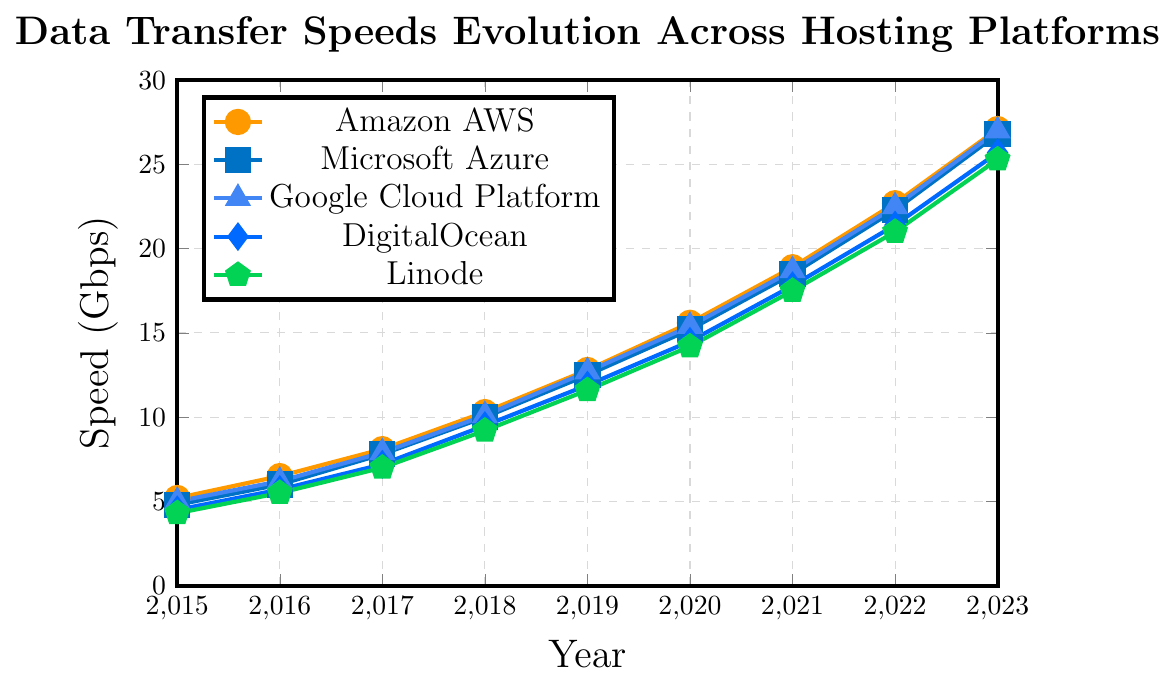Which hosting platform had the highest data transfer speed in 2023? Look at the data transfer speeds for the year 2023 across all platforms. Amazon AWS has the highest speed with 27.1 Gbps.
Answer: Amazon AWS What is the difference in data transfer speeds between Google Cloud Platform and Linode in 2019? In 2019, Google Cloud Platform had a speed of 12.7 Gbps, and Linode had a speed of 11.6 Gbps. Subtract Linode's speed from Google Cloud Platform's speed: 12.7 - 11.6 = 1.1 Gbps.
Answer: 1.1 Gbps Which hosting platform showed the most significant increase in data transfer speed between 2021 and 2023? Calculate the difference in data transfer speeds between 2021 and 2023 for each platform: 
- Amazon AWS: 27.1 - 18.9 = 8.2 
- Microsoft Azure: 26.8 - 18.5 = 8.3 
- Google Cloud Platform: 27.0 - 18.7 = 8.3 
- DigitalOcean: 25.7 - 17.8 = 7.9 
- Linode: 25.3 - 17.5 = 7.8 
Microsoft Azure and Google Cloud Platform tie with the highest increase of 8.3 Gbps.
Answer: Microsoft Azure and Google Cloud Platform Compare the average data transfer speeds of DigitalOcean from 2015 to 2018 with those of Linode in the same period. 1. Calculate the average for DigitalOcean from 2015 to 2018: 
(4.5 + 5.7 + 7.2 + 9.5) / 4 = 26.9 / 4 = 6.725 Gbps 
2. Calculate the average for Linode from 2015 to 2018: 
(4.3 + 5.5 + 7.0 + 9.2) / 4 = 26.0 / 4 = 6.5 Gbps 
3. Compare the averages: 6.725 > 6.5 
DigitalOcean has a higher average data transfer speed.
Answer: DigitalOcean How did the data transfer speed improvement of Microsoft Azure from 2016 to 2020 compare to Google Cloud Platform in the same period? 1. Calculate the improvement for Microsoft Azure: 
2020 speed - 2016 speed = 15.2 - 6.0 = 9.2 Gbps 
2. Calculate the improvement for Google Cloud Platform: 
2020 speed - 2016 speed = 15.4 - 6.2 = 9.2 Gbps 
Both platforms showed an improvement of 9.2 Gbps.
Answer: They are equal What was the trend in data transfer speeds for all hosting platforms from 2015 to 2023? All hosting platforms showed a consistent increase in data transfer speeds from 2015 to 2023. Each year, the speeds rose steadily across all platforms.
Answer: Consistent increase By what percentage did DigitalOcean's data transfer speed increase from 2015 to 2023? 1. Calculate the increase: 2023 speed - 2015 speed = 25.7 - 4.5 = 21.2 Gbps 
2. Calculate the percentage increase: (21.2 / 4.5) * 100 ≈ 471.11%
Answer: 471.11% Which two hosting platforms had the closest data transfer speeds in 2017? Look at the data for 2017:
Amazon AWS: 8.1 Gbps 
Microsoft Azure: 7.8 Gbps 
Google Cloud Platform: 7.9 Gbps 
DigitalOcean: 7.2 Gbps 
Linode: 7.0 Gbps 
Microsoft Azure and Google Cloud Platform had the closest speeds, differing by only 0.1 Gbps.
Answer: Microsoft Azure and Google Cloud Platform 